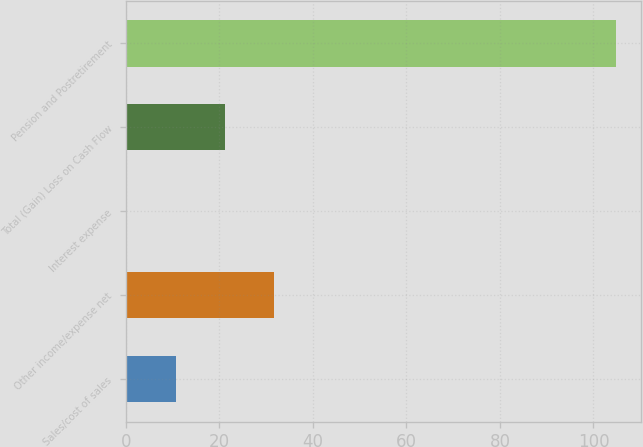<chart> <loc_0><loc_0><loc_500><loc_500><bar_chart><fcel>Sales/cost of sales<fcel>Other income/expense net<fcel>Interest expense<fcel>Total (Gain) Loss on Cash Flow<fcel>Pension and Postretirement<nl><fcel>10.76<fcel>31.68<fcel>0.3<fcel>21.22<fcel>104.9<nl></chart> 